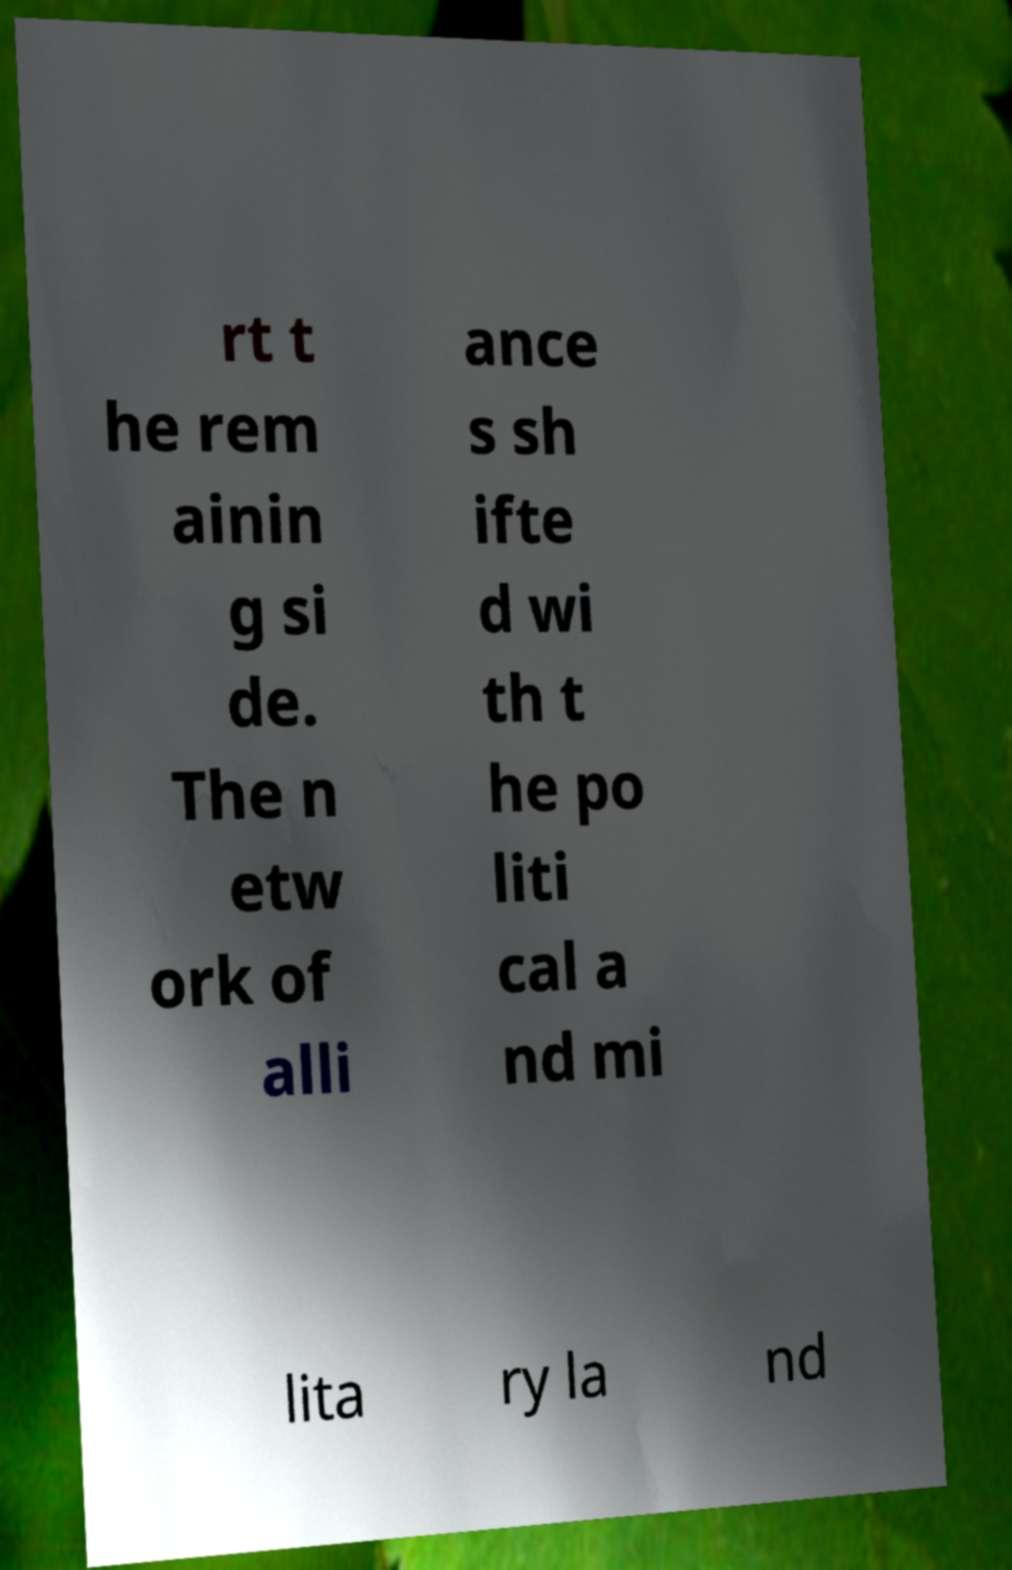For documentation purposes, I need the text within this image transcribed. Could you provide that? rt t he rem ainin g si de. The n etw ork of alli ance s sh ifte d wi th t he po liti cal a nd mi lita ry la nd 